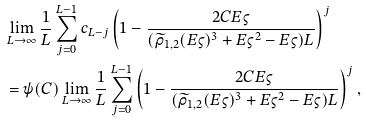Convert formula to latex. <formula><loc_0><loc_0><loc_500><loc_500>& \lim _ { L \to \infty } \frac { 1 } { L } \sum _ { j = 0 } ^ { L - 1 } c _ { L - j } \left ( 1 - \frac { 2 C E \varsigma } { ( \widetilde { \rho } _ { 1 , 2 } ( E \varsigma ) ^ { 3 } + E \varsigma ^ { 2 } - E \varsigma ) L } \right ) ^ { j } \\ & = \psi ( C ) \lim _ { L \to \infty } \frac { 1 } { L } \sum _ { j = 0 } ^ { L - 1 } \left ( 1 - \frac { 2 C E \varsigma } { ( \widetilde { \rho } _ { 1 , 2 } ( E \varsigma ) ^ { 3 } + E \varsigma ^ { 2 } - E \varsigma ) L } \right ) ^ { j } ,</formula> 